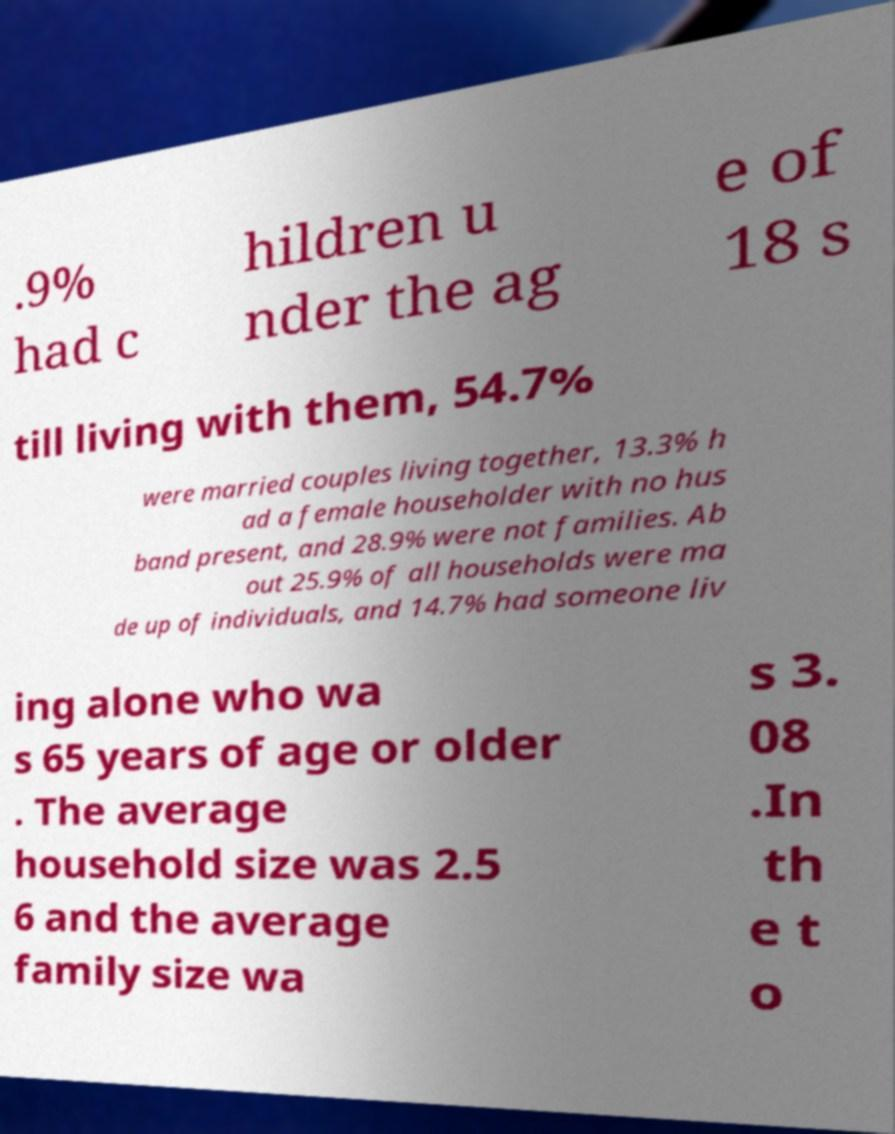I need the written content from this picture converted into text. Can you do that? .9% had c hildren u nder the ag e of 18 s till living with them, 54.7% were married couples living together, 13.3% h ad a female householder with no hus band present, and 28.9% were not families. Ab out 25.9% of all households were ma de up of individuals, and 14.7% had someone liv ing alone who wa s 65 years of age or older . The average household size was 2.5 6 and the average family size wa s 3. 08 .In th e t o 